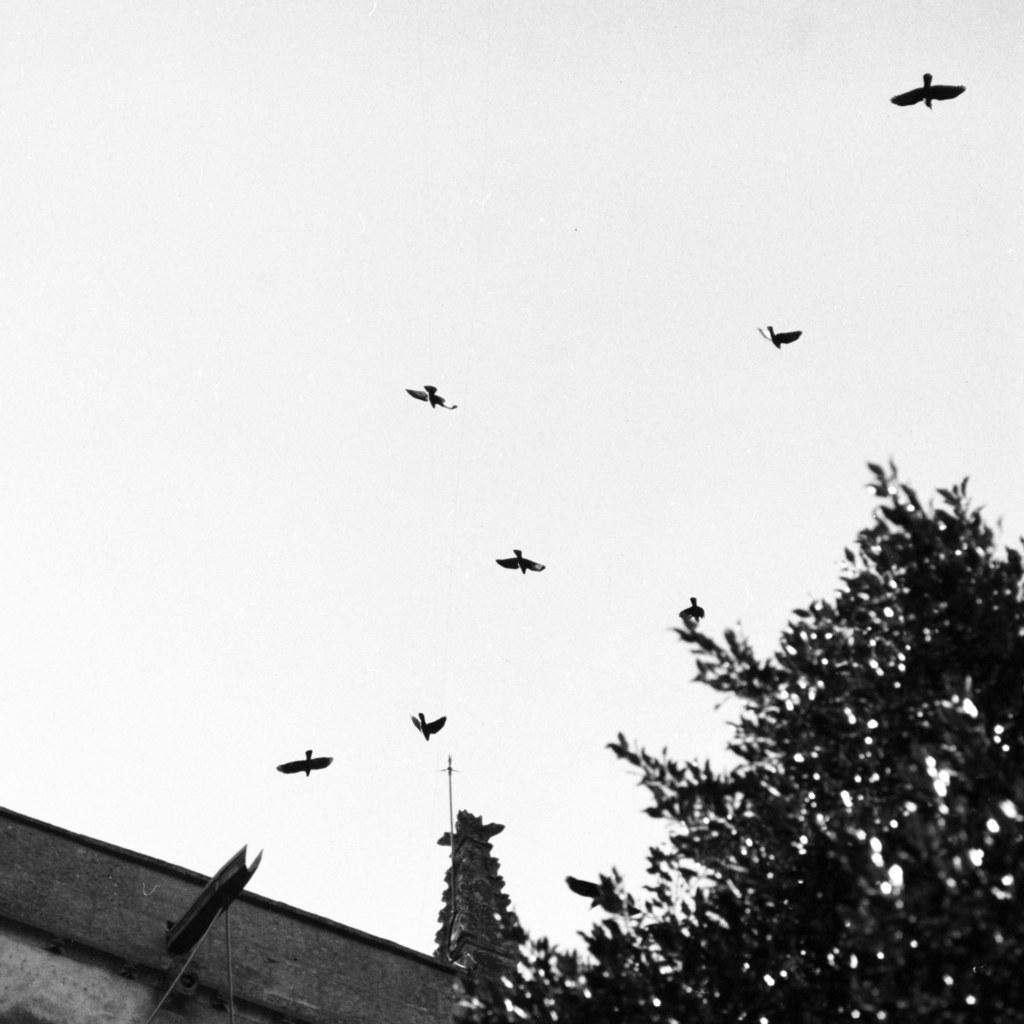Please provide a concise description of this image. In this picture there are birds flying in the sky, there are trees and there is a building. 